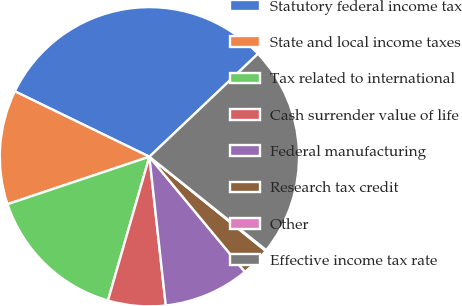Convert chart. <chart><loc_0><loc_0><loc_500><loc_500><pie_chart><fcel>Statutory federal income tax<fcel>State and local income taxes<fcel>Tax related to international<fcel>Cash surrender value of life<fcel>Federal manufacturing<fcel>Research tax credit<fcel>Other<fcel>Effective income tax rate<nl><fcel>30.72%<fcel>12.34%<fcel>15.4%<fcel>6.21%<fcel>9.28%<fcel>3.15%<fcel>0.09%<fcel>22.82%<nl></chart> 